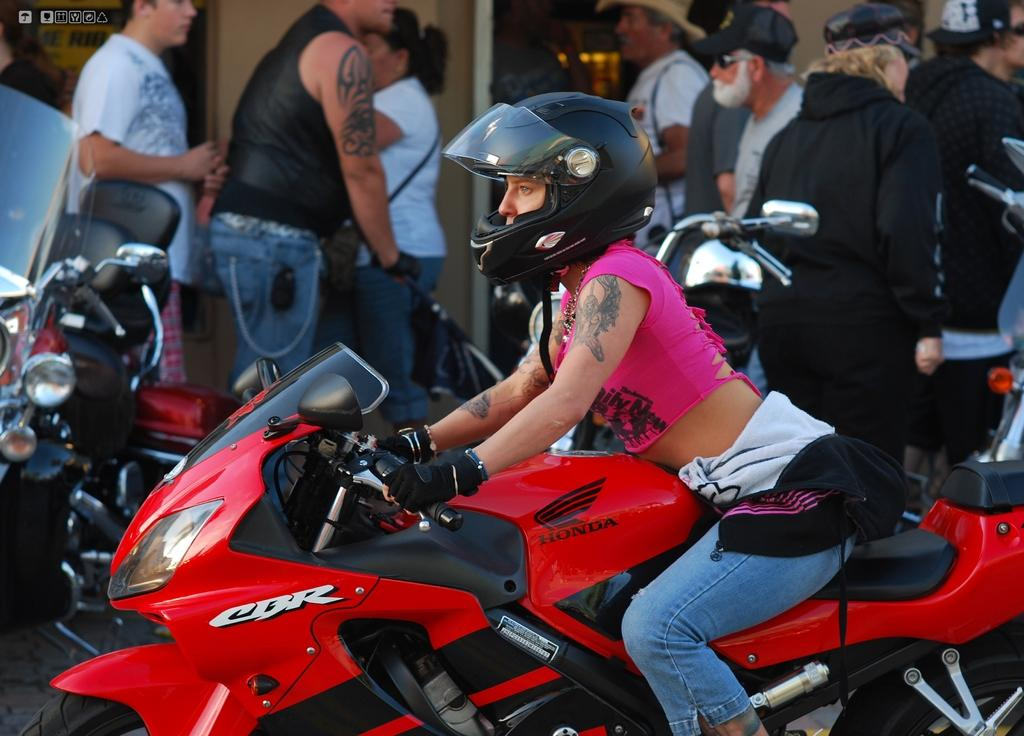Who is the main subject in the image? There is a woman in the image. What is the woman doing in the image? The woman is riding a red-colored bike. What safety precaution is the woman taking while riding the bike? The woman is wearing a helmet. What can be seen in the background of the image? There are people in the background of the image. What position are the people in the background in? The people in the background are in a standing position. What type of grass is being served by the woman in the image? There is no grass or serving activity present in the image. Is there a band playing music in the background of the image? There is no band or music playing in the image. 